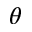<formula> <loc_0><loc_0><loc_500><loc_500>\theta</formula> 